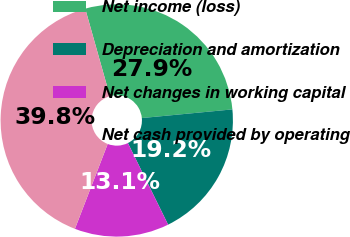Convert chart to OTSL. <chart><loc_0><loc_0><loc_500><loc_500><pie_chart><fcel>Net income (loss)<fcel>Depreciation and amortization<fcel>Net changes in working capital<fcel>Net cash provided by operating<nl><fcel>27.86%<fcel>19.23%<fcel>13.15%<fcel>39.76%<nl></chart> 